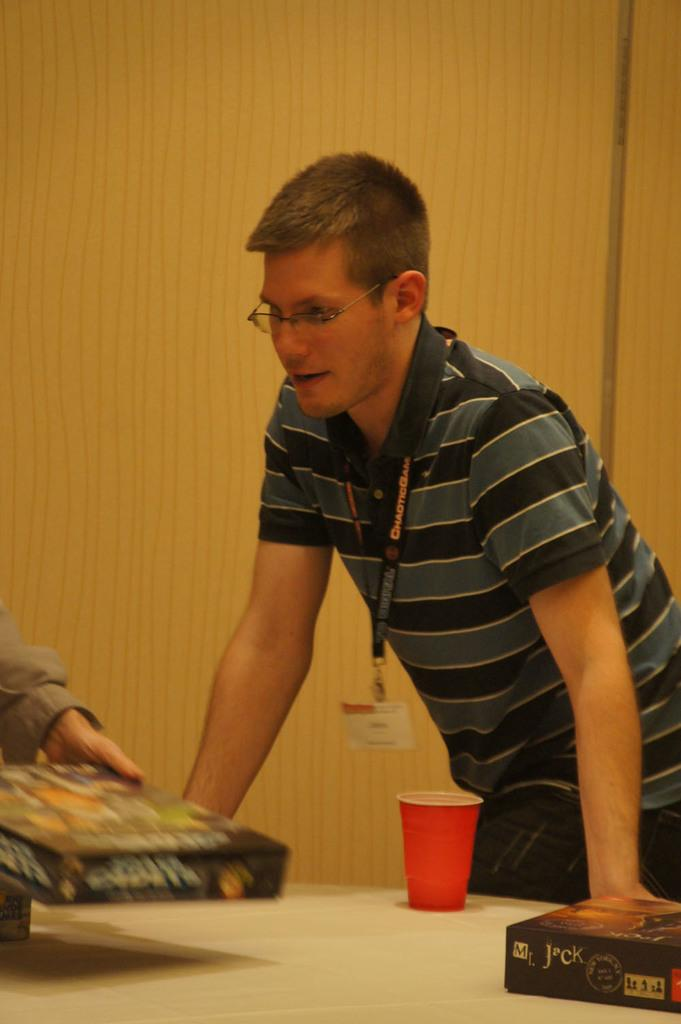Who is present in the image? There is a man in the image. What is the man wearing? The man is wearing something. What object is in front of the man? There is a box in front of the man. Can you describe another object in the image? There is a glass on a table in the image. What is the temperature of the sun in the image? There is no sun present in the image, so it is not possible to determine its temperature. 